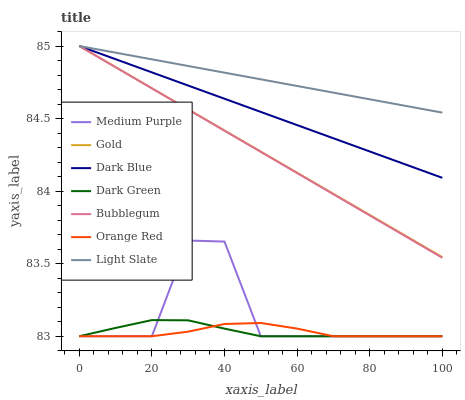Does Orange Red have the minimum area under the curve?
Answer yes or no. Yes. Does Light Slate have the maximum area under the curve?
Answer yes or no. Yes. Does Bubblegum have the minimum area under the curve?
Answer yes or no. No. Does Bubblegum have the maximum area under the curve?
Answer yes or no. No. Is Dark Blue the smoothest?
Answer yes or no. Yes. Is Medium Purple the roughest?
Answer yes or no. Yes. Is Light Slate the smoothest?
Answer yes or no. No. Is Light Slate the roughest?
Answer yes or no. No. Does Medium Purple have the lowest value?
Answer yes or no. Yes. Does Bubblegum have the lowest value?
Answer yes or no. No. Does Dark Blue have the highest value?
Answer yes or no. Yes. Does Medium Purple have the highest value?
Answer yes or no. No. Is Orange Red less than Light Slate?
Answer yes or no. Yes. Is Light Slate greater than Medium Purple?
Answer yes or no. Yes. Does Dark Green intersect Medium Purple?
Answer yes or no. Yes. Is Dark Green less than Medium Purple?
Answer yes or no. No. Is Dark Green greater than Medium Purple?
Answer yes or no. No. Does Orange Red intersect Light Slate?
Answer yes or no. No. 